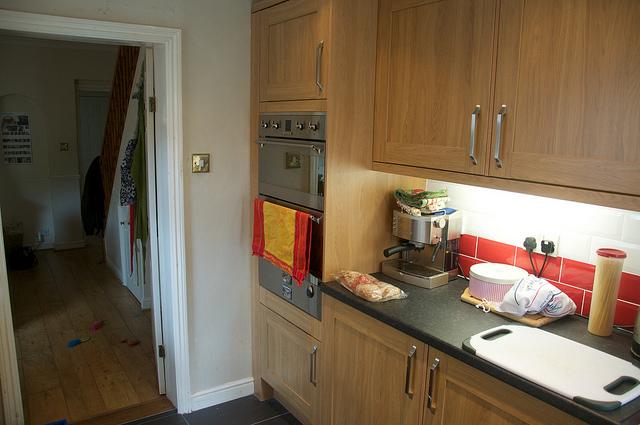Are the towels dirty?
Be succinct. No. How many red towels are on the oven?
Answer briefly. 1. What color are the cabinets?
Quick response, please. Brown. Is the floor tiled?
Be succinct. Yes. Is this kitchen neat?
Quick response, please. Yes. Is the cabinets closed?
Answer briefly. Yes. Is there a corded telephone in the shot?
Be succinct. No. What color are the borders of the cutting board?
Write a very short answer. Black. Is there a light switch?
Give a very brief answer. Yes. Is anyone cooking?
Short answer required. No. Is there a fridge in the picture?
Write a very short answer. No. What is the pattern of the red and white tiles?
Answer briefly. Square. 